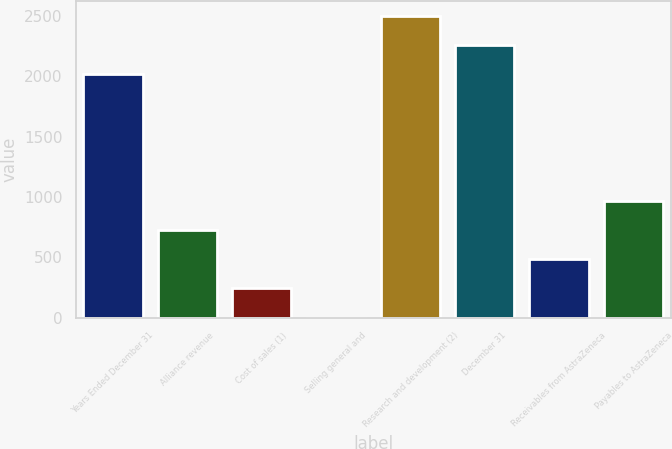Convert chart. <chart><loc_0><loc_0><loc_500><loc_500><bar_chart><fcel>Years Ended December 31<fcel>Alliance revenue<fcel>Cost of sales (1)<fcel>Selling general and<fcel>Research and development (2)<fcel>December 31<fcel>Receivables from AstraZeneca<fcel>Payables to AstraZeneca<nl><fcel>2017<fcel>726.4<fcel>242.8<fcel>1<fcel>2500.6<fcel>2258.8<fcel>484.6<fcel>968.2<nl></chart> 